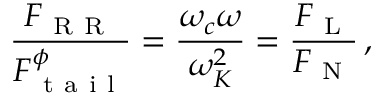<formula> <loc_0><loc_0><loc_500><loc_500>\frac { F _ { R R } } { F _ { t a i l } ^ { \phi } } = \frac { \omega _ { c } \omega } { \omega _ { K } ^ { 2 } } = \frac { F _ { L } } { F _ { N } } \, ,</formula> 